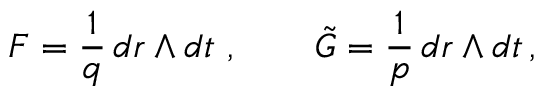<formula> <loc_0><loc_0><loc_500><loc_500>F = \frac { 1 } { q } \, d r \wedge d t \ , \quad \tilde { G } = \frac { 1 } { p } \, d r \wedge d t \, ,</formula> 